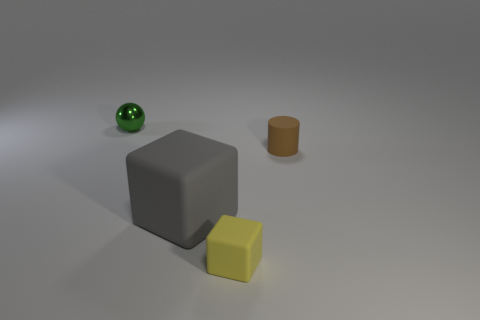Are there any other things that have the same material as the small green thing?
Offer a terse response. No. What is the tiny thing that is to the left of the tiny brown thing and behind the big rubber block made of?
Your response must be concise. Metal. What number of gray rubber things are the same shape as the yellow thing?
Offer a very short reply. 1. The small thing that is behind the object right of the yellow rubber cube is what color?
Your response must be concise. Green. Is the number of big matte blocks that are to the right of the tiny brown cylinder the same as the number of big matte objects?
Ensure brevity in your answer.  No. Are there any brown metallic cylinders that have the same size as the yellow cube?
Give a very brief answer. No. Does the gray rubber thing have the same size as the object that is in front of the big gray rubber cube?
Your response must be concise. No. Are there the same number of small yellow rubber objects right of the brown rubber cylinder and large cubes on the right side of the large rubber thing?
Offer a terse response. Yes. There is a tiny thing that is left of the tiny yellow cube; what is it made of?
Your answer should be very brief. Metal. Is the size of the yellow object the same as the brown matte thing?
Keep it short and to the point. Yes. 